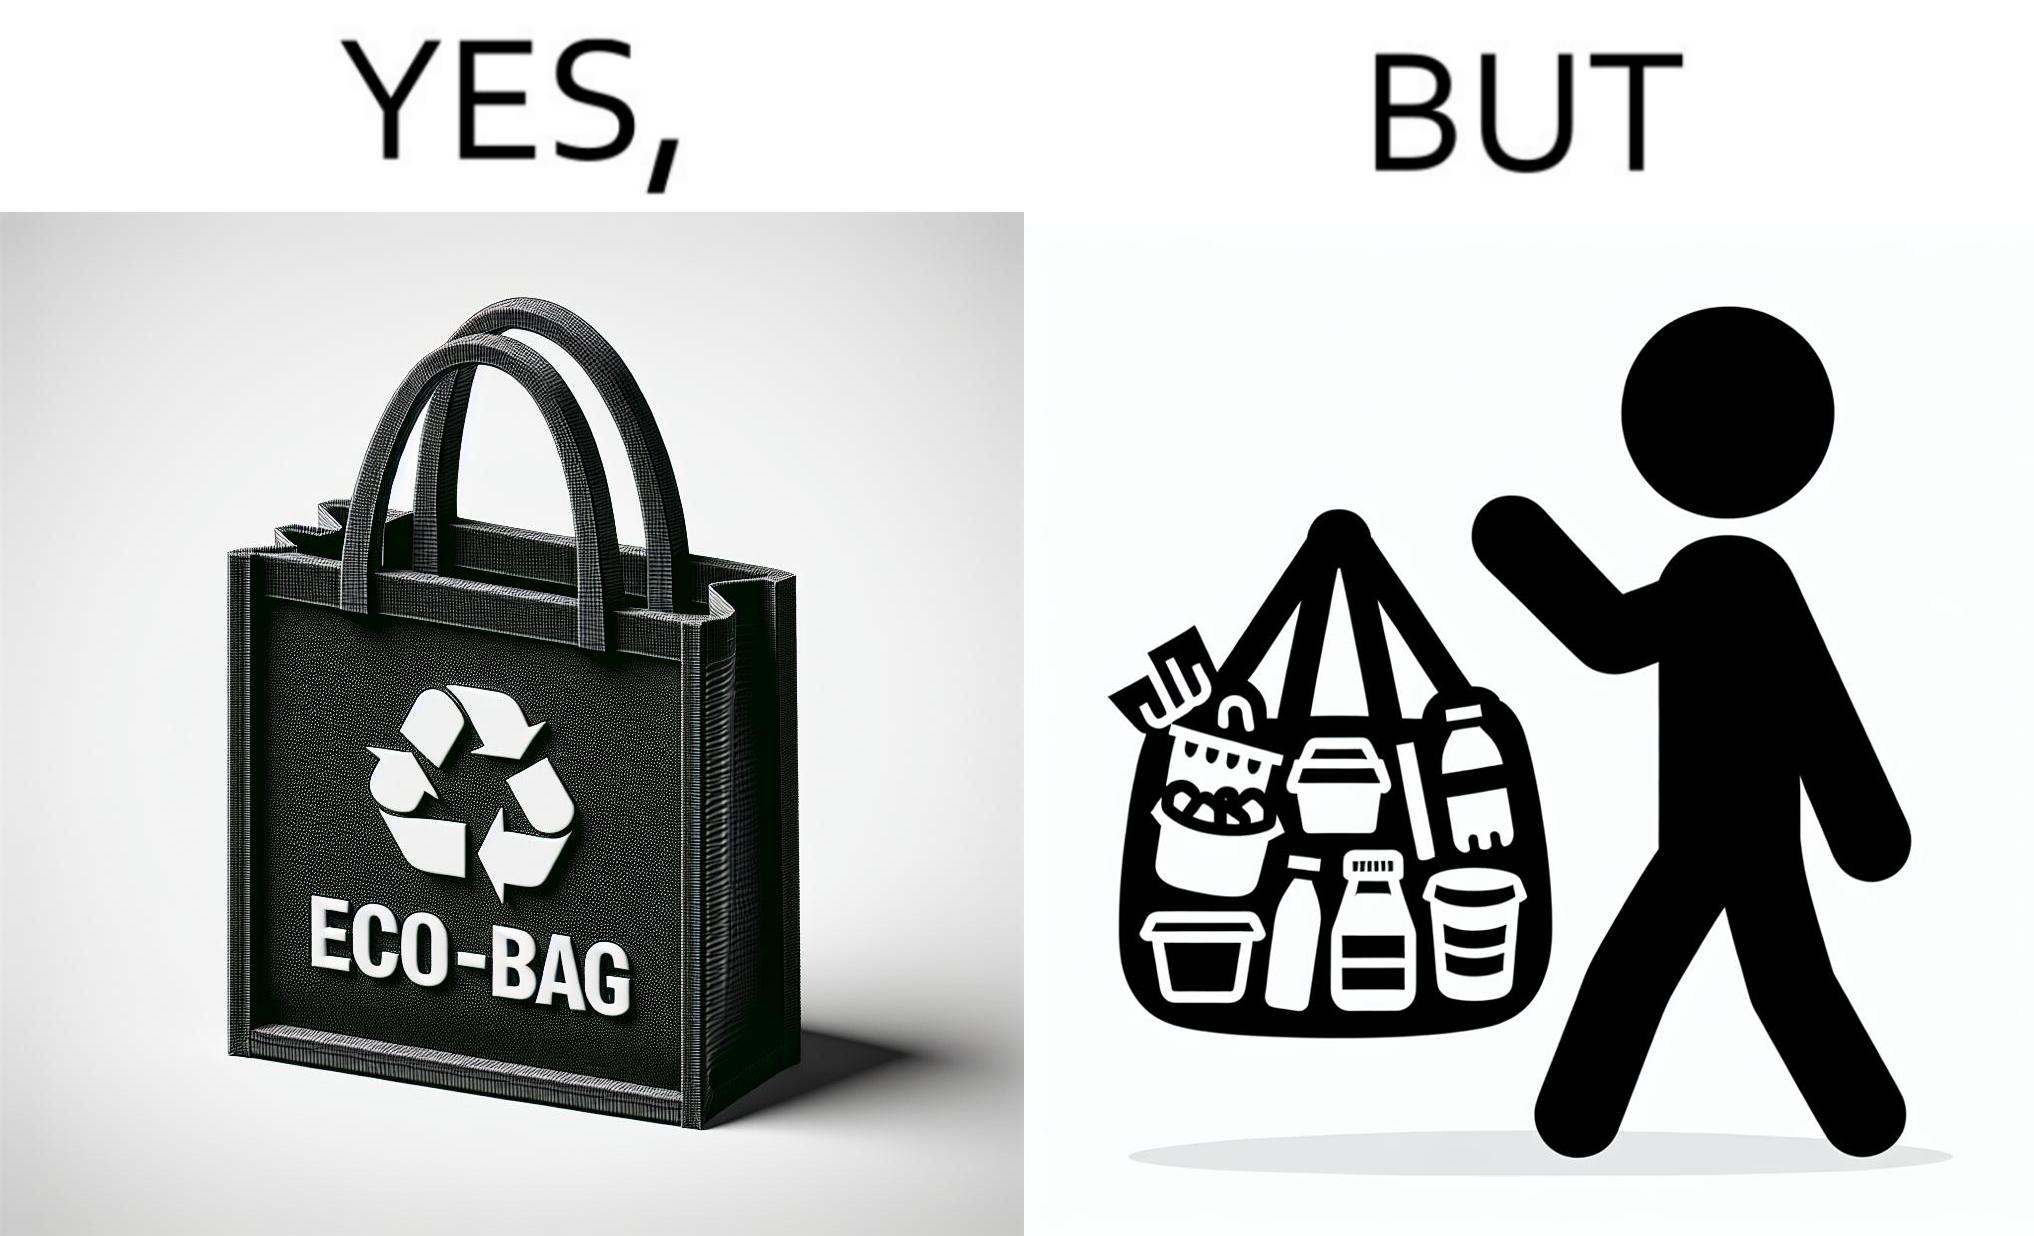Describe the contrast between the left and right parts of this image. In the left part of the image: a bag with text "eco-bag" on it, probably made up of some eco-friendly materials like cotton or jute In the right part of the image: a person carrying different products inside plastic containers or plastic wrapping in a carry bag 